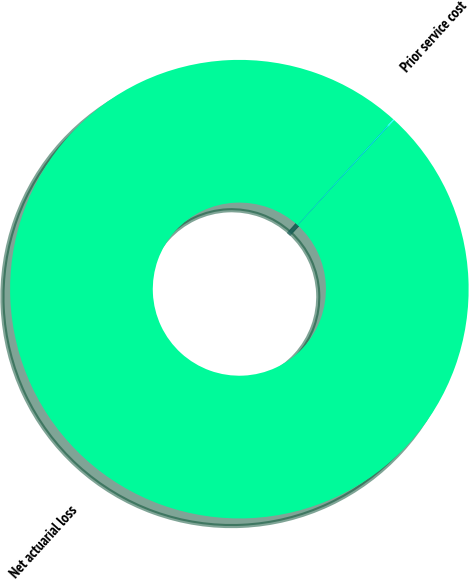<chart> <loc_0><loc_0><loc_500><loc_500><pie_chart><fcel>Net actuarial loss<fcel>Prior service cost<nl><fcel>99.93%<fcel>0.07%<nl></chart> 